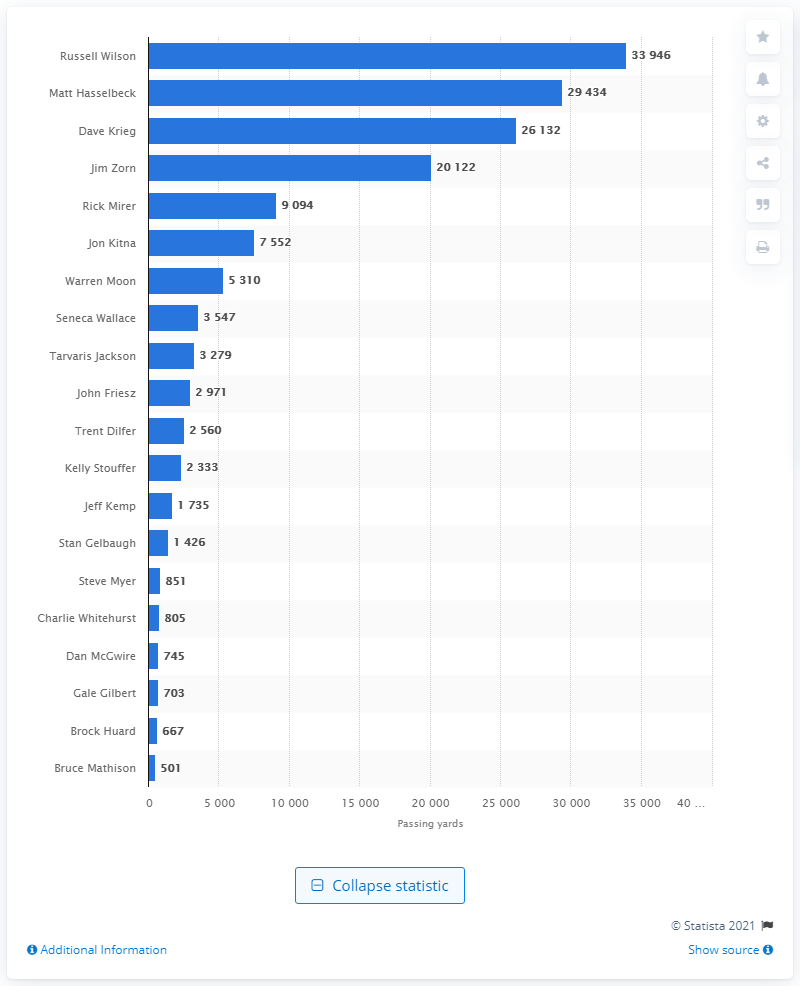Outline some significant characteristics in this image. Russell Wilson is the career passing leader of the Seattle Seahawks. 